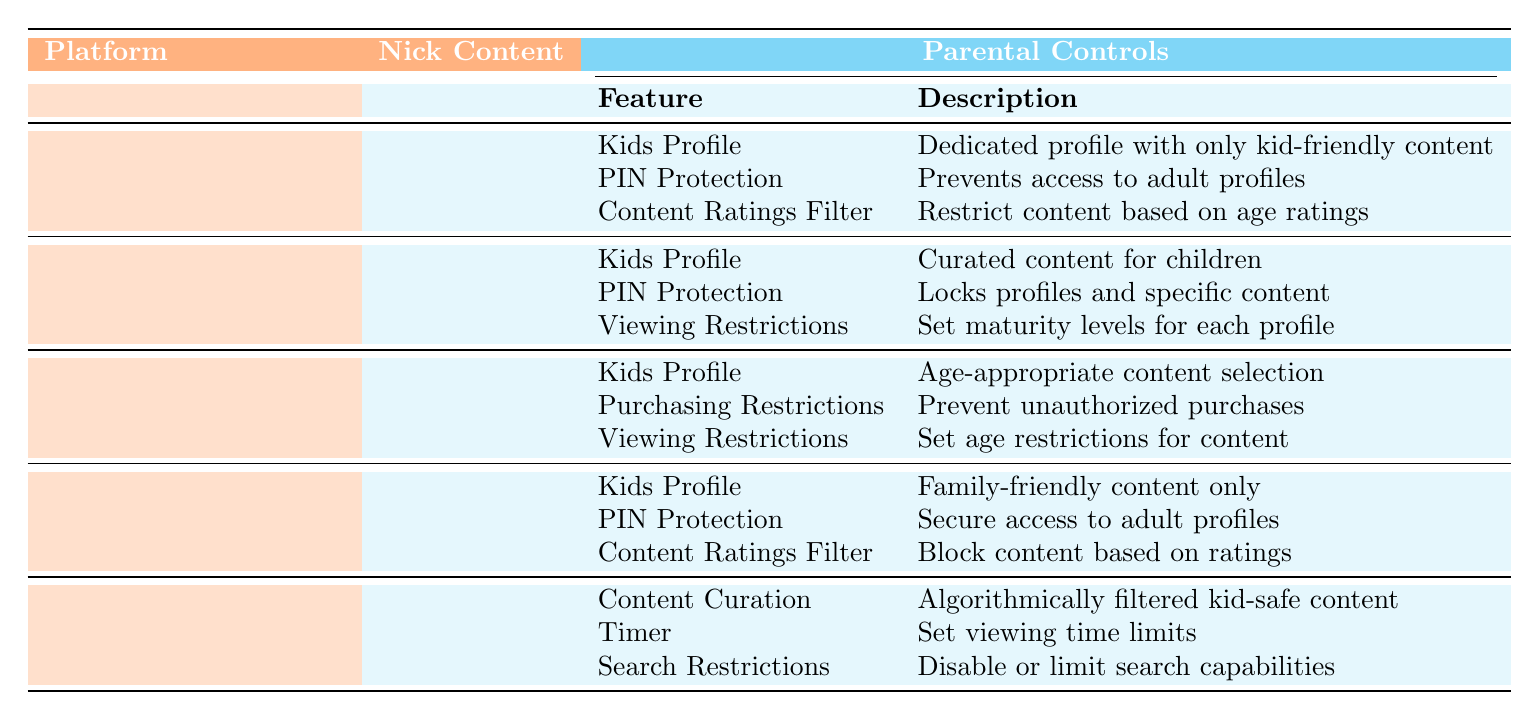What streaming platform offers extensive Nickelodeon content? The table lists Paramount+ as having "Extensive" Nickelodeon Content.
Answer: Paramount+ Which platform has the least amount of Nickelodeon content available? According to the table, Netflix is listed with "Limited" Nickelodeon content, indicating it has the least.
Answer: Netflix How many parental control features does Paramount+ have? By counting the parental control features listed for Paramount+ in the table, there are three: Kids Profile, PIN Protection, and Content Ratings Filter.
Answer: 3 Does Hulu provide PIN protection among its parental control features? The table shows that Hulu includes "PIN Protection" as one of its parental control features. Therefore, the answer is yes.
Answer: Yes Which platform allows parents to set viewing time limits for their children? The table indicates that YouTube Kids offers a "Timer" feature to set viewing time limits.
Answer: YouTube Kids Are there more parental control features listed for Amazon Prime Video or Hulu? Amazon Prime Video has three parental control features, while Hulu also has three. Both platforms have the same number, so the comparison shows they are equal.
Answer: Equal Which parental control feature is common to both Paramount+ and Hulu? Both platforms list "Kids Profile" as a parental control feature, which allows for kid-friendly content access.
Answer: Kids Profile What are the differences in parental control features between Netflix and Amazon Prime Video? Netflix includes Viewing Restrictions, while Amazon Prime Video has Purchasing Restrictions instead. This shows both platforms have distinct features in their parental control offerings.
Answer: Different features If viewing restrictions are set on Netflix, what could they restrict? The table mentions that Netflix's Viewing Restrictions allow setting maturity levels for each profile, meaning parents can limit what content their kids can watch based on age ratings.
Answer: Maturity levels Which service has the most features for parental controls? Both Paramount+ and Amazon Prime Video have three parental control features each, while other services typically have fewer, making them the leaders in feature quantity.
Answer: Paramount+ and Amazon Prime Video 